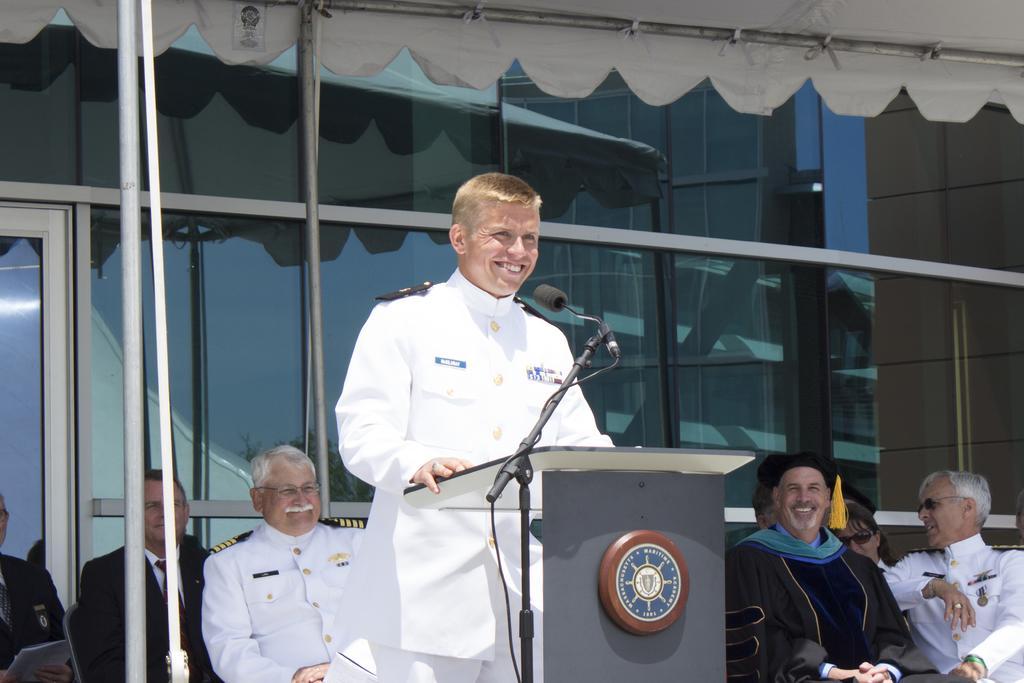How would you summarize this image in a sentence or two? In this image we can see this person wearing white uniform is standing near the podium and smiling where mic is kept to the stand. Here we can see these persons are sitting on the chairs, we can see the tents and the glass building in the background. 